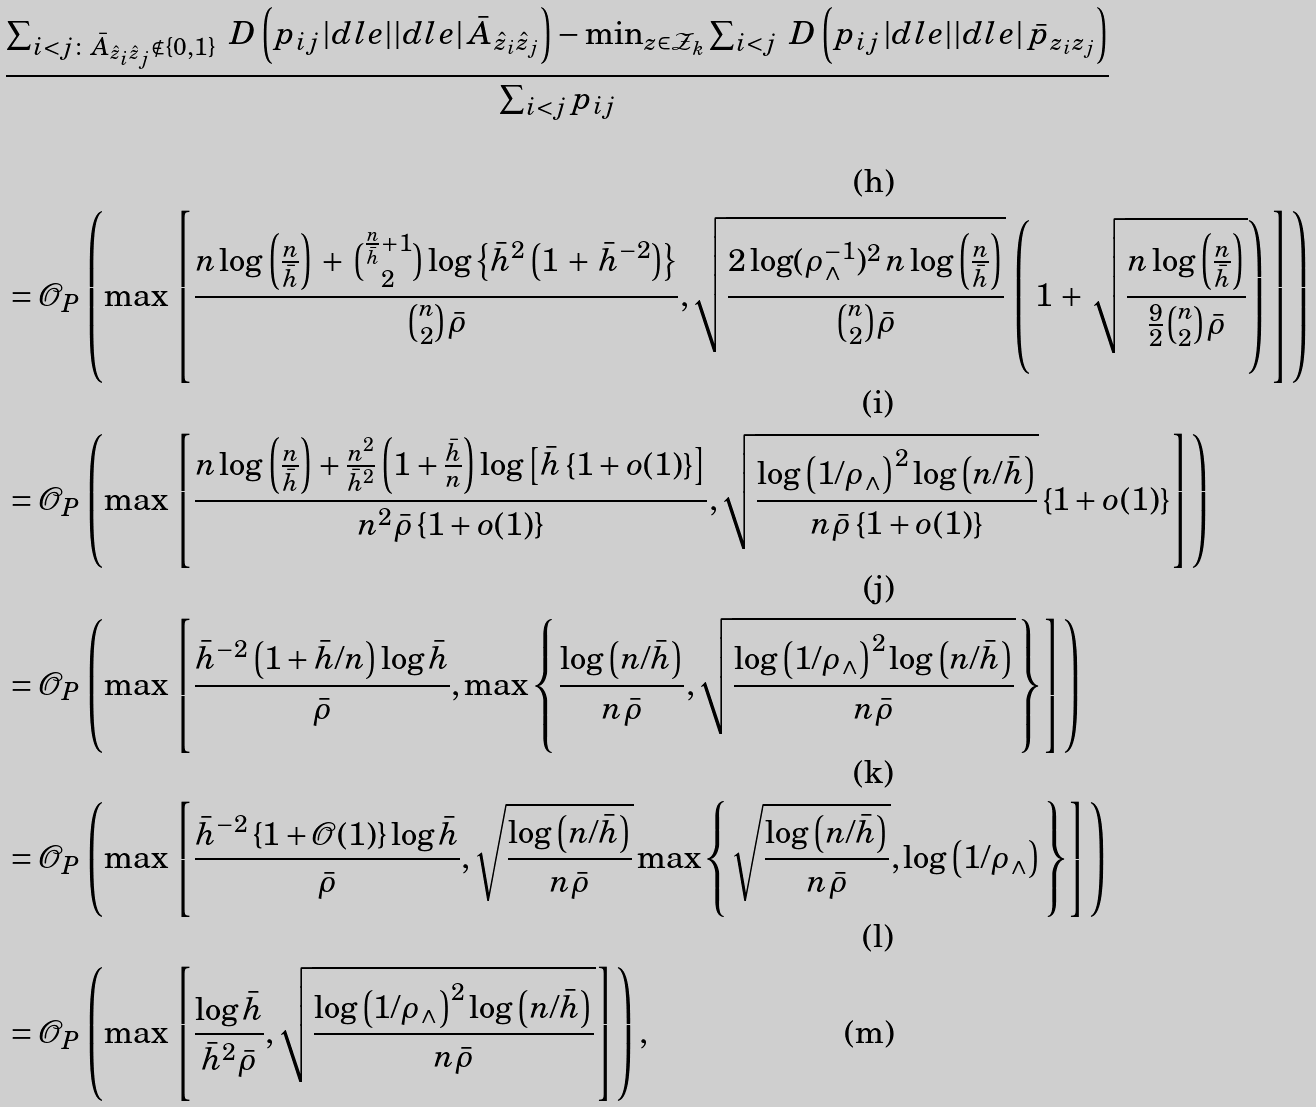<formula> <loc_0><loc_0><loc_500><loc_500>& \frac { \sum _ { i < j \colon \bar { A } _ { \hat { z } _ { i } \hat { z } _ { j } } \notin \{ 0 , 1 \} } \ D \left ( p _ { i j } \, | d l e | | d l e | \, \bar { A } _ { \hat { z } _ { i } \hat { z } _ { j } } \right ) - \min _ { z \in \mathcal { Z } _ { k } } \sum _ { i < j } \ D \left ( p _ { i j } \, | d l e | | d l e | \, \bar { p } _ { z _ { i } z _ { j } } \right ) } { \sum _ { i < j } p _ { i j } } \\ & = \mathcal { O } _ { P } \left ( \max \left [ \frac { n \log \left ( \frac { n } { \bar { h } } \right ) \, + \, \binom { \frac { n } { \bar { h } } + 1 } { 2 } \log \left \{ \bar { h } ^ { 2 } \left ( 1 \, + \, \bar { h } ^ { - 2 } \right ) \right \} } { \binom { n } { 2 } \bar { \rho } } , \sqrt { \frac { 2 \log ( \rho _ { \wedge } ^ { - 1 } ) ^ { 2 } \, n \log \left ( \frac { n } { \bar { h } } \right ) } { \binom { n } { 2 } \bar { \rho } } } \, \left ( \, 1 \, + \, \sqrt { \frac { n \log \left ( \frac { n } { \bar { h } } \right ) } { \frac { 9 } { 2 } \binom { n } { 2 } \bar { \rho } } } \right ) \, \right ] \right ) \\ & = \mathcal { O } _ { P } \left ( \max \left [ \frac { n \log \left ( \frac { n } { \bar { h } } \right ) + \frac { n ^ { 2 } } { \bar { h } ^ { 2 } } \left ( 1 + \frac { \bar { h } } { n } \right ) \log \left [ \bar { h } \left \{ 1 + o ( 1 ) \right \} \right ] } { n ^ { 2 } \bar { \rho } \left \{ 1 + o ( 1 ) \right \} } , \sqrt { \frac { \log \left ( 1 / \rho _ { \wedge } \right ) ^ { 2 } \log \left ( n / \bar { h } \right ) } { n \bar { \rho } \left \{ 1 + o ( 1 ) \right \} } } \left \{ 1 + o ( 1 ) \right \} \right ] \right ) \\ & = \mathcal { O } _ { P } \left ( \max \left [ \frac { \bar { h } ^ { - 2 } \left ( 1 + \bar { h } / n \right ) \log \bar { h } } { \bar { \rho } } , \max \left \{ \frac { \log \left ( n / \bar { h } \right ) } { n \bar { \rho } } , \sqrt { \frac { \log \left ( 1 / \rho _ { \wedge } \right ) ^ { 2 } \log \left ( n / \bar { h } \right ) } { n \bar { \rho } } } \right \} \right ] \right ) \\ & = \mathcal { O } _ { P } \left ( \max \left [ \frac { \bar { h } ^ { - 2 } \left \{ 1 + \mathcal { O } ( 1 ) \right \} \log \bar { h } } { \bar { \rho } } , \sqrt { \frac { \log \left ( n / \bar { h } \right ) } { n \bar { \rho } } } \max \left \{ \sqrt { \frac { \log \left ( n / \bar { h } \right ) } { n \bar { \rho } } } , \log \left ( 1 / \rho _ { \wedge } \right ) \right \} \right ] \right ) \\ & = \mathcal { O } _ { P } \left ( \max \left [ \frac { \log \bar { h } } { \bar { h } ^ { 2 } \bar { \rho } } , \sqrt { \frac { \log \left ( 1 / \rho _ { \wedge } \right ) ^ { 2 } \log \left ( n / \bar { h } \right ) } { n \bar { \rho } } } \right ] \right ) ,</formula> 